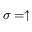<formula> <loc_0><loc_0><loc_500><loc_500>\sigma = \uparrow</formula> 